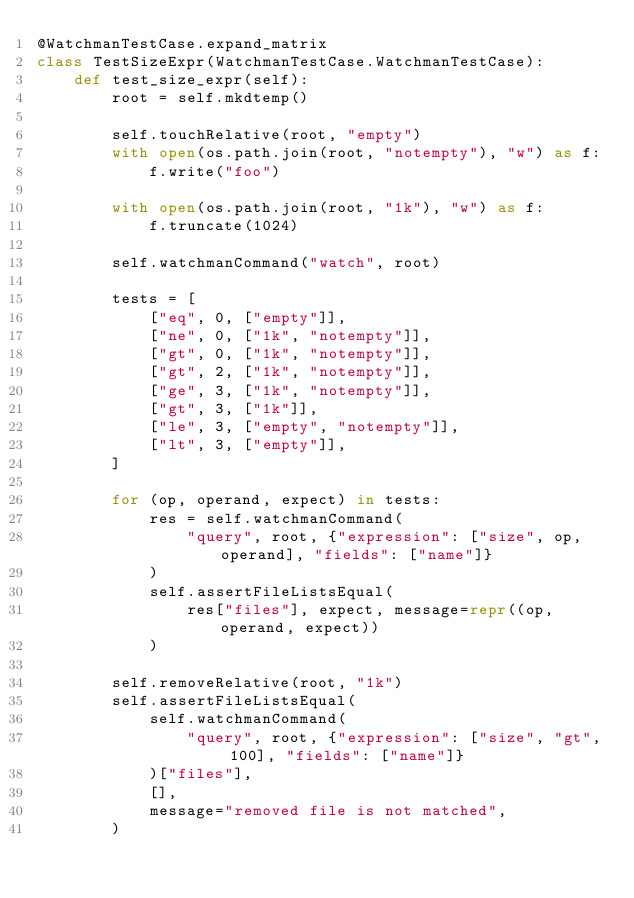Convert code to text. <code><loc_0><loc_0><loc_500><loc_500><_Python_>@WatchmanTestCase.expand_matrix
class TestSizeExpr(WatchmanTestCase.WatchmanTestCase):
    def test_size_expr(self):
        root = self.mkdtemp()

        self.touchRelative(root, "empty")
        with open(os.path.join(root, "notempty"), "w") as f:
            f.write("foo")

        with open(os.path.join(root, "1k"), "w") as f:
            f.truncate(1024)

        self.watchmanCommand("watch", root)

        tests = [
            ["eq", 0, ["empty"]],
            ["ne", 0, ["1k", "notempty"]],
            ["gt", 0, ["1k", "notempty"]],
            ["gt", 2, ["1k", "notempty"]],
            ["ge", 3, ["1k", "notempty"]],
            ["gt", 3, ["1k"]],
            ["le", 3, ["empty", "notempty"]],
            ["lt", 3, ["empty"]],
        ]

        for (op, operand, expect) in tests:
            res = self.watchmanCommand(
                "query", root, {"expression": ["size", op, operand], "fields": ["name"]}
            )
            self.assertFileListsEqual(
                res["files"], expect, message=repr((op, operand, expect))
            )

        self.removeRelative(root, "1k")
        self.assertFileListsEqual(
            self.watchmanCommand(
                "query", root, {"expression": ["size", "gt", 100], "fields": ["name"]}
            )["files"],
            [],
            message="removed file is not matched",
        )
</code> 